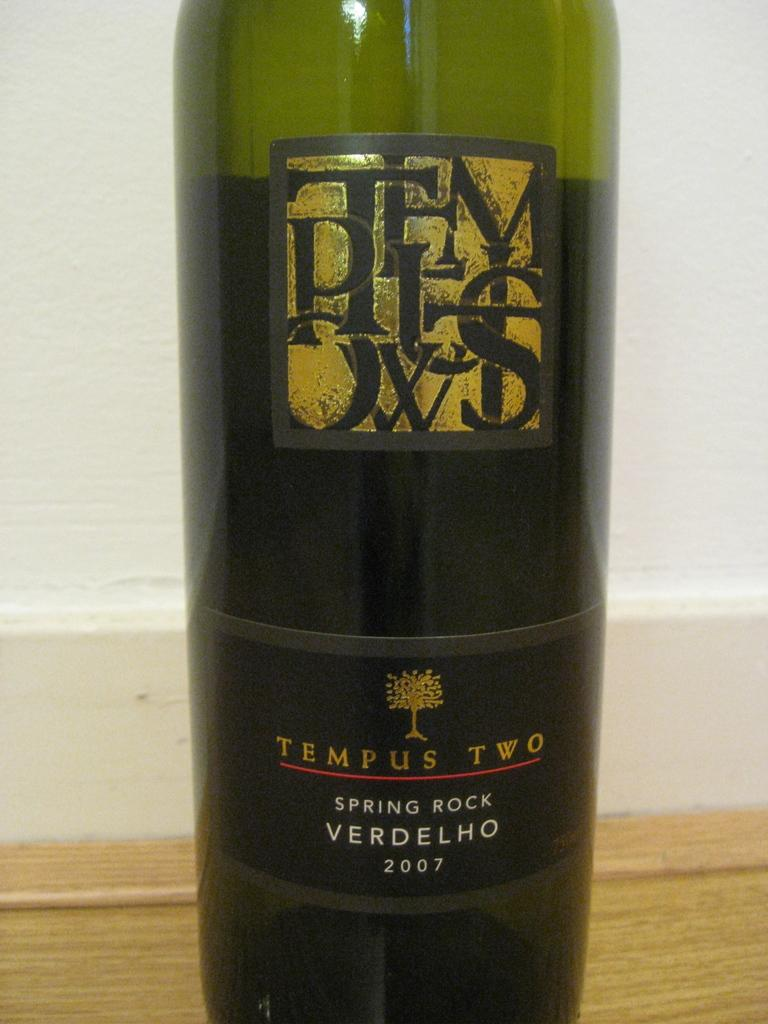<image>
Give a short and clear explanation of the subsequent image. A bottle of Spring Rock Verdelho wine by Tempus Two. 